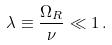<formula> <loc_0><loc_0><loc_500><loc_500>\lambda \equiv \frac { \Omega _ { R } } { \nu } \ll 1 \, .</formula> 